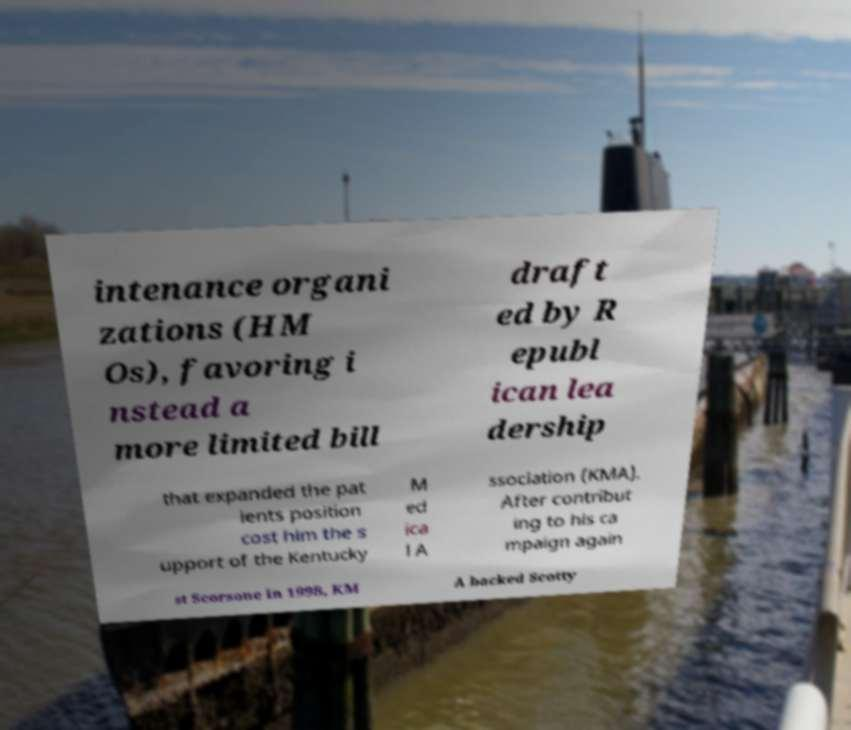Please identify and transcribe the text found in this image. intenance organi zations (HM Os), favoring i nstead a more limited bill draft ed by R epubl ican lea dership that expanded the pat ients position cost him the s upport of the Kentucky M ed ica l A ssociation (KMA). After contribut ing to his ca mpaign again st Scorsone in 1998, KM A backed Scotty 